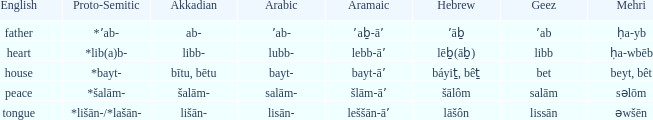If the proto-semitic is *bayt-, what are the geez? Bet. 